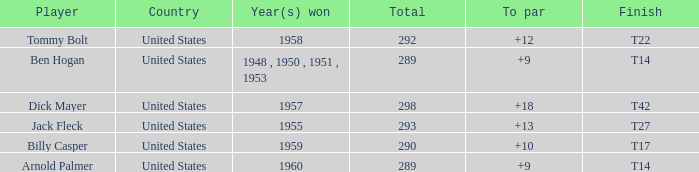What is Country, when Total is less than 290, and when Year(s) Won is 1960? United States. 